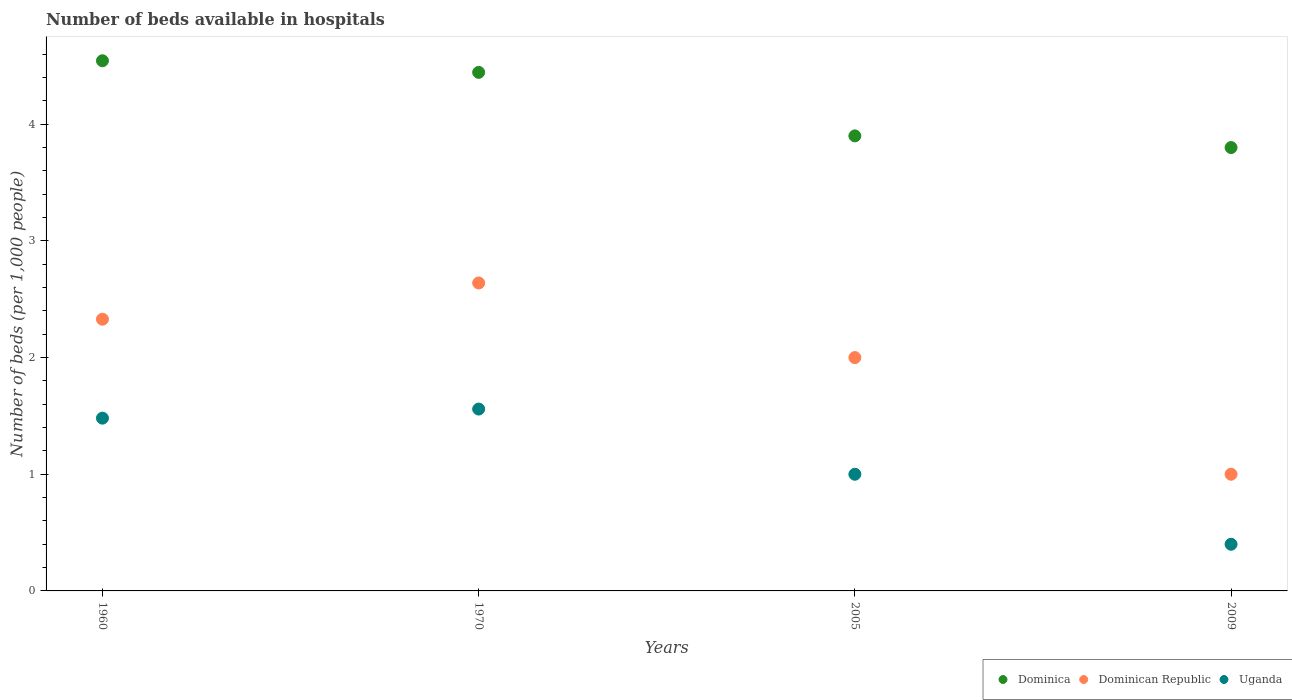What is the number of beds in the hospiatls of in Uganda in 1960?
Give a very brief answer. 1.48. Across all years, what is the maximum number of beds in the hospiatls of in Dominica?
Provide a short and direct response. 4.54. What is the total number of beds in the hospiatls of in Dominica in the graph?
Your response must be concise. 16.69. What is the difference between the number of beds in the hospiatls of in Uganda in 1970 and that in 2005?
Your response must be concise. 0.56. What is the difference between the number of beds in the hospiatls of in Uganda in 1960 and the number of beds in the hospiatls of in Dominica in 2005?
Offer a very short reply. -2.42. What is the average number of beds in the hospiatls of in Dominican Republic per year?
Provide a short and direct response. 1.99. In the year 1970, what is the difference between the number of beds in the hospiatls of in Dominican Republic and number of beds in the hospiatls of in Uganda?
Your response must be concise. 1.08. In how many years, is the number of beds in the hospiatls of in Dominica greater than 3.6?
Offer a terse response. 4. What is the ratio of the number of beds in the hospiatls of in Dominica in 1960 to that in 2005?
Offer a very short reply. 1.17. What is the difference between the highest and the second highest number of beds in the hospiatls of in Uganda?
Your answer should be compact. 0.08. What is the difference between the highest and the lowest number of beds in the hospiatls of in Uganda?
Your answer should be very brief. 1.16. In how many years, is the number of beds in the hospiatls of in Uganda greater than the average number of beds in the hospiatls of in Uganda taken over all years?
Offer a terse response. 2. Is it the case that in every year, the sum of the number of beds in the hospiatls of in Dominica and number of beds in the hospiatls of in Uganda  is greater than the number of beds in the hospiatls of in Dominican Republic?
Make the answer very short. Yes. Does the number of beds in the hospiatls of in Dominican Republic monotonically increase over the years?
Provide a succinct answer. No. Is the number of beds in the hospiatls of in Dominica strictly greater than the number of beds in the hospiatls of in Dominican Republic over the years?
Your answer should be very brief. Yes. Is the number of beds in the hospiatls of in Dominican Republic strictly less than the number of beds in the hospiatls of in Uganda over the years?
Offer a very short reply. No. How many dotlines are there?
Offer a terse response. 3. How many years are there in the graph?
Provide a succinct answer. 4. What is the difference between two consecutive major ticks on the Y-axis?
Give a very brief answer. 1. Are the values on the major ticks of Y-axis written in scientific E-notation?
Keep it short and to the point. No. Does the graph contain grids?
Provide a succinct answer. No. How many legend labels are there?
Provide a succinct answer. 3. How are the legend labels stacked?
Your answer should be compact. Horizontal. What is the title of the graph?
Offer a very short reply. Number of beds available in hospitals. What is the label or title of the X-axis?
Your answer should be compact. Years. What is the label or title of the Y-axis?
Make the answer very short. Number of beds (per 1,0 people). What is the Number of beds (per 1,000 people) of Dominica in 1960?
Ensure brevity in your answer.  4.54. What is the Number of beds (per 1,000 people) of Dominican Republic in 1960?
Your response must be concise. 2.33. What is the Number of beds (per 1,000 people) in Uganda in 1960?
Keep it short and to the point. 1.48. What is the Number of beds (per 1,000 people) of Dominica in 1970?
Provide a succinct answer. 4.44. What is the Number of beds (per 1,000 people) in Dominican Republic in 1970?
Your response must be concise. 2.64. What is the Number of beds (per 1,000 people) in Uganda in 1970?
Provide a short and direct response. 1.56. What is the Number of beds (per 1,000 people) in Dominican Republic in 2005?
Provide a short and direct response. 2. What is the Number of beds (per 1,000 people) in Dominican Republic in 2009?
Make the answer very short. 1. Across all years, what is the maximum Number of beds (per 1,000 people) of Dominica?
Keep it short and to the point. 4.54. Across all years, what is the maximum Number of beds (per 1,000 people) of Dominican Republic?
Give a very brief answer. 2.64. Across all years, what is the maximum Number of beds (per 1,000 people) in Uganda?
Offer a terse response. 1.56. Across all years, what is the minimum Number of beds (per 1,000 people) in Dominica?
Provide a succinct answer. 3.8. Across all years, what is the minimum Number of beds (per 1,000 people) in Uganda?
Your answer should be compact. 0.4. What is the total Number of beds (per 1,000 people) in Dominica in the graph?
Keep it short and to the point. 16.69. What is the total Number of beds (per 1,000 people) of Dominican Republic in the graph?
Make the answer very short. 7.97. What is the total Number of beds (per 1,000 people) of Uganda in the graph?
Your answer should be compact. 4.44. What is the difference between the Number of beds (per 1,000 people) of Dominica in 1960 and that in 1970?
Your answer should be compact. 0.1. What is the difference between the Number of beds (per 1,000 people) of Dominican Republic in 1960 and that in 1970?
Offer a terse response. -0.31. What is the difference between the Number of beds (per 1,000 people) in Uganda in 1960 and that in 1970?
Give a very brief answer. -0.08. What is the difference between the Number of beds (per 1,000 people) of Dominica in 1960 and that in 2005?
Offer a very short reply. 0.64. What is the difference between the Number of beds (per 1,000 people) of Dominican Republic in 1960 and that in 2005?
Your answer should be compact. 0.33. What is the difference between the Number of beds (per 1,000 people) in Uganda in 1960 and that in 2005?
Make the answer very short. 0.48. What is the difference between the Number of beds (per 1,000 people) of Dominica in 1960 and that in 2009?
Provide a short and direct response. 0.74. What is the difference between the Number of beds (per 1,000 people) in Dominican Republic in 1960 and that in 2009?
Your answer should be very brief. 1.33. What is the difference between the Number of beds (per 1,000 people) in Uganda in 1960 and that in 2009?
Make the answer very short. 1.08. What is the difference between the Number of beds (per 1,000 people) in Dominica in 1970 and that in 2005?
Provide a short and direct response. 0.54. What is the difference between the Number of beds (per 1,000 people) of Dominican Republic in 1970 and that in 2005?
Keep it short and to the point. 0.64. What is the difference between the Number of beds (per 1,000 people) in Uganda in 1970 and that in 2005?
Offer a terse response. 0.56. What is the difference between the Number of beds (per 1,000 people) of Dominica in 1970 and that in 2009?
Offer a terse response. 0.64. What is the difference between the Number of beds (per 1,000 people) in Dominican Republic in 1970 and that in 2009?
Provide a short and direct response. 1.64. What is the difference between the Number of beds (per 1,000 people) in Uganda in 1970 and that in 2009?
Make the answer very short. 1.16. What is the difference between the Number of beds (per 1,000 people) of Dominica in 2005 and that in 2009?
Offer a very short reply. 0.1. What is the difference between the Number of beds (per 1,000 people) in Dominican Republic in 2005 and that in 2009?
Offer a very short reply. 1. What is the difference between the Number of beds (per 1,000 people) in Uganda in 2005 and that in 2009?
Offer a very short reply. 0.6. What is the difference between the Number of beds (per 1,000 people) of Dominica in 1960 and the Number of beds (per 1,000 people) of Dominican Republic in 1970?
Give a very brief answer. 1.9. What is the difference between the Number of beds (per 1,000 people) of Dominica in 1960 and the Number of beds (per 1,000 people) of Uganda in 1970?
Provide a short and direct response. 2.99. What is the difference between the Number of beds (per 1,000 people) of Dominican Republic in 1960 and the Number of beds (per 1,000 people) of Uganda in 1970?
Your answer should be very brief. 0.77. What is the difference between the Number of beds (per 1,000 people) in Dominica in 1960 and the Number of beds (per 1,000 people) in Dominican Republic in 2005?
Offer a very short reply. 2.54. What is the difference between the Number of beds (per 1,000 people) in Dominica in 1960 and the Number of beds (per 1,000 people) in Uganda in 2005?
Keep it short and to the point. 3.54. What is the difference between the Number of beds (per 1,000 people) in Dominican Republic in 1960 and the Number of beds (per 1,000 people) in Uganda in 2005?
Offer a terse response. 1.33. What is the difference between the Number of beds (per 1,000 people) in Dominica in 1960 and the Number of beds (per 1,000 people) in Dominican Republic in 2009?
Offer a very short reply. 3.54. What is the difference between the Number of beds (per 1,000 people) in Dominica in 1960 and the Number of beds (per 1,000 people) in Uganda in 2009?
Your answer should be very brief. 4.14. What is the difference between the Number of beds (per 1,000 people) in Dominican Republic in 1960 and the Number of beds (per 1,000 people) in Uganda in 2009?
Ensure brevity in your answer.  1.93. What is the difference between the Number of beds (per 1,000 people) of Dominica in 1970 and the Number of beds (per 1,000 people) of Dominican Republic in 2005?
Provide a short and direct response. 2.44. What is the difference between the Number of beds (per 1,000 people) in Dominica in 1970 and the Number of beds (per 1,000 people) in Uganda in 2005?
Make the answer very short. 3.44. What is the difference between the Number of beds (per 1,000 people) of Dominican Republic in 1970 and the Number of beds (per 1,000 people) of Uganda in 2005?
Your answer should be very brief. 1.64. What is the difference between the Number of beds (per 1,000 people) of Dominica in 1970 and the Number of beds (per 1,000 people) of Dominican Republic in 2009?
Give a very brief answer. 3.44. What is the difference between the Number of beds (per 1,000 people) of Dominica in 1970 and the Number of beds (per 1,000 people) of Uganda in 2009?
Provide a succinct answer. 4.04. What is the difference between the Number of beds (per 1,000 people) of Dominican Republic in 1970 and the Number of beds (per 1,000 people) of Uganda in 2009?
Your response must be concise. 2.24. What is the difference between the Number of beds (per 1,000 people) of Dominica in 2005 and the Number of beds (per 1,000 people) of Dominican Republic in 2009?
Your response must be concise. 2.9. What is the difference between the Number of beds (per 1,000 people) of Dominica in 2005 and the Number of beds (per 1,000 people) of Uganda in 2009?
Provide a succinct answer. 3.5. What is the average Number of beds (per 1,000 people) in Dominica per year?
Offer a terse response. 4.17. What is the average Number of beds (per 1,000 people) in Dominican Republic per year?
Make the answer very short. 1.99. What is the average Number of beds (per 1,000 people) of Uganda per year?
Your response must be concise. 1.11. In the year 1960, what is the difference between the Number of beds (per 1,000 people) of Dominica and Number of beds (per 1,000 people) of Dominican Republic?
Give a very brief answer. 2.22. In the year 1960, what is the difference between the Number of beds (per 1,000 people) of Dominica and Number of beds (per 1,000 people) of Uganda?
Your response must be concise. 3.06. In the year 1960, what is the difference between the Number of beds (per 1,000 people) of Dominican Republic and Number of beds (per 1,000 people) of Uganda?
Ensure brevity in your answer.  0.85. In the year 1970, what is the difference between the Number of beds (per 1,000 people) in Dominica and Number of beds (per 1,000 people) in Dominican Republic?
Make the answer very short. 1.8. In the year 1970, what is the difference between the Number of beds (per 1,000 people) of Dominica and Number of beds (per 1,000 people) of Uganda?
Your answer should be compact. 2.89. In the year 1970, what is the difference between the Number of beds (per 1,000 people) in Dominican Republic and Number of beds (per 1,000 people) in Uganda?
Ensure brevity in your answer.  1.08. In the year 2005, what is the difference between the Number of beds (per 1,000 people) of Dominica and Number of beds (per 1,000 people) of Dominican Republic?
Keep it short and to the point. 1.9. In the year 2009, what is the difference between the Number of beds (per 1,000 people) in Dominican Republic and Number of beds (per 1,000 people) in Uganda?
Your response must be concise. 0.6. What is the ratio of the Number of beds (per 1,000 people) of Dominica in 1960 to that in 1970?
Ensure brevity in your answer.  1.02. What is the ratio of the Number of beds (per 1,000 people) in Dominican Republic in 1960 to that in 1970?
Your answer should be compact. 0.88. What is the ratio of the Number of beds (per 1,000 people) in Uganda in 1960 to that in 1970?
Your answer should be very brief. 0.95. What is the ratio of the Number of beds (per 1,000 people) of Dominica in 1960 to that in 2005?
Provide a succinct answer. 1.17. What is the ratio of the Number of beds (per 1,000 people) of Dominican Republic in 1960 to that in 2005?
Provide a short and direct response. 1.16. What is the ratio of the Number of beds (per 1,000 people) of Uganda in 1960 to that in 2005?
Offer a terse response. 1.48. What is the ratio of the Number of beds (per 1,000 people) of Dominica in 1960 to that in 2009?
Your response must be concise. 1.2. What is the ratio of the Number of beds (per 1,000 people) of Dominican Republic in 1960 to that in 2009?
Provide a short and direct response. 2.33. What is the ratio of the Number of beds (per 1,000 people) of Uganda in 1960 to that in 2009?
Your answer should be compact. 3.7. What is the ratio of the Number of beds (per 1,000 people) in Dominica in 1970 to that in 2005?
Provide a short and direct response. 1.14. What is the ratio of the Number of beds (per 1,000 people) in Dominican Republic in 1970 to that in 2005?
Offer a terse response. 1.32. What is the ratio of the Number of beds (per 1,000 people) of Uganda in 1970 to that in 2005?
Provide a succinct answer. 1.56. What is the ratio of the Number of beds (per 1,000 people) of Dominica in 1970 to that in 2009?
Ensure brevity in your answer.  1.17. What is the ratio of the Number of beds (per 1,000 people) of Dominican Republic in 1970 to that in 2009?
Provide a succinct answer. 2.64. What is the ratio of the Number of beds (per 1,000 people) in Uganda in 1970 to that in 2009?
Ensure brevity in your answer.  3.9. What is the ratio of the Number of beds (per 1,000 people) of Dominica in 2005 to that in 2009?
Provide a succinct answer. 1.03. What is the difference between the highest and the second highest Number of beds (per 1,000 people) of Dominica?
Your response must be concise. 0.1. What is the difference between the highest and the second highest Number of beds (per 1,000 people) of Dominican Republic?
Ensure brevity in your answer.  0.31. What is the difference between the highest and the second highest Number of beds (per 1,000 people) in Uganda?
Give a very brief answer. 0.08. What is the difference between the highest and the lowest Number of beds (per 1,000 people) in Dominica?
Your answer should be compact. 0.74. What is the difference between the highest and the lowest Number of beds (per 1,000 people) of Dominican Republic?
Keep it short and to the point. 1.64. What is the difference between the highest and the lowest Number of beds (per 1,000 people) in Uganda?
Make the answer very short. 1.16. 